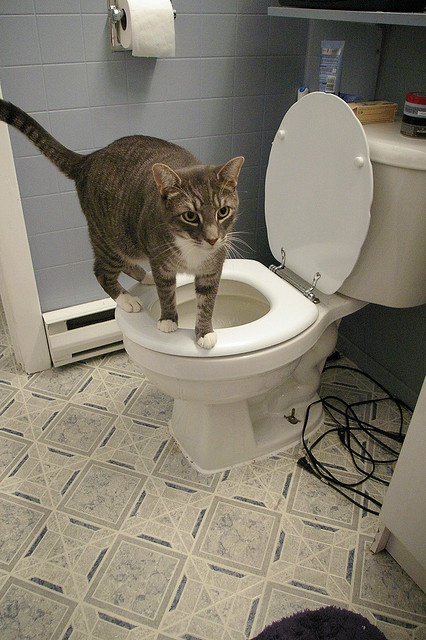Describe the objects in this image and their specific colors. I can see toilet in gray and darkgray tones and cat in gray and black tones in this image. 